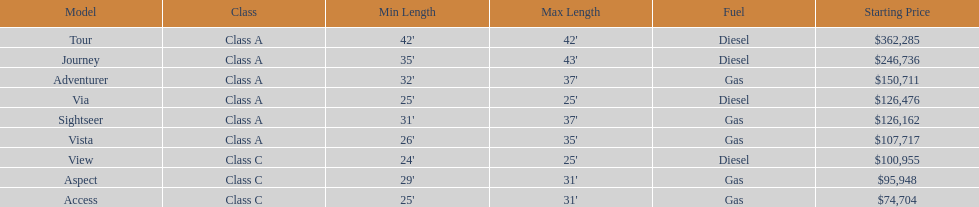How many models are available in lengths longer than 30 feet? 7. Could you parse the entire table as a dict? {'header': ['Model', 'Class', 'Min Length', 'Max Length', 'Fuel', 'Starting Price'], 'rows': [['Tour', 'Class A', "42'", "42'", 'Diesel', '$362,285'], ['Journey', 'Class A', "35'", "43'", 'Diesel', '$246,736'], ['Adventurer', 'Class A', "32'", "37'", 'Gas', '$150,711'], ['Via', 'Class A', "25'", "25'", 'Diesel', '$126,476'], ['Sightseer', 'Class A', "31'", "37'", 'Gas', '$126,162'], ['Vista', 'Class A', "26'", "35'", 'Gas', '$107,717'], ['View', 'Class C', "24'", "25'", 'Diesel', '$100,955'], ['Aspect', 'Class C', "29'", "31'", 'Gas', '$95,948'], ['Access', 'Class C', "25'", "31'", 'Gas', '$74,704']]} 